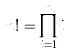<formula> <loc_0><loc_0><loc_500><loc_500>n ! = \prod _ { i = 1 } ^ { n } i</formula> 